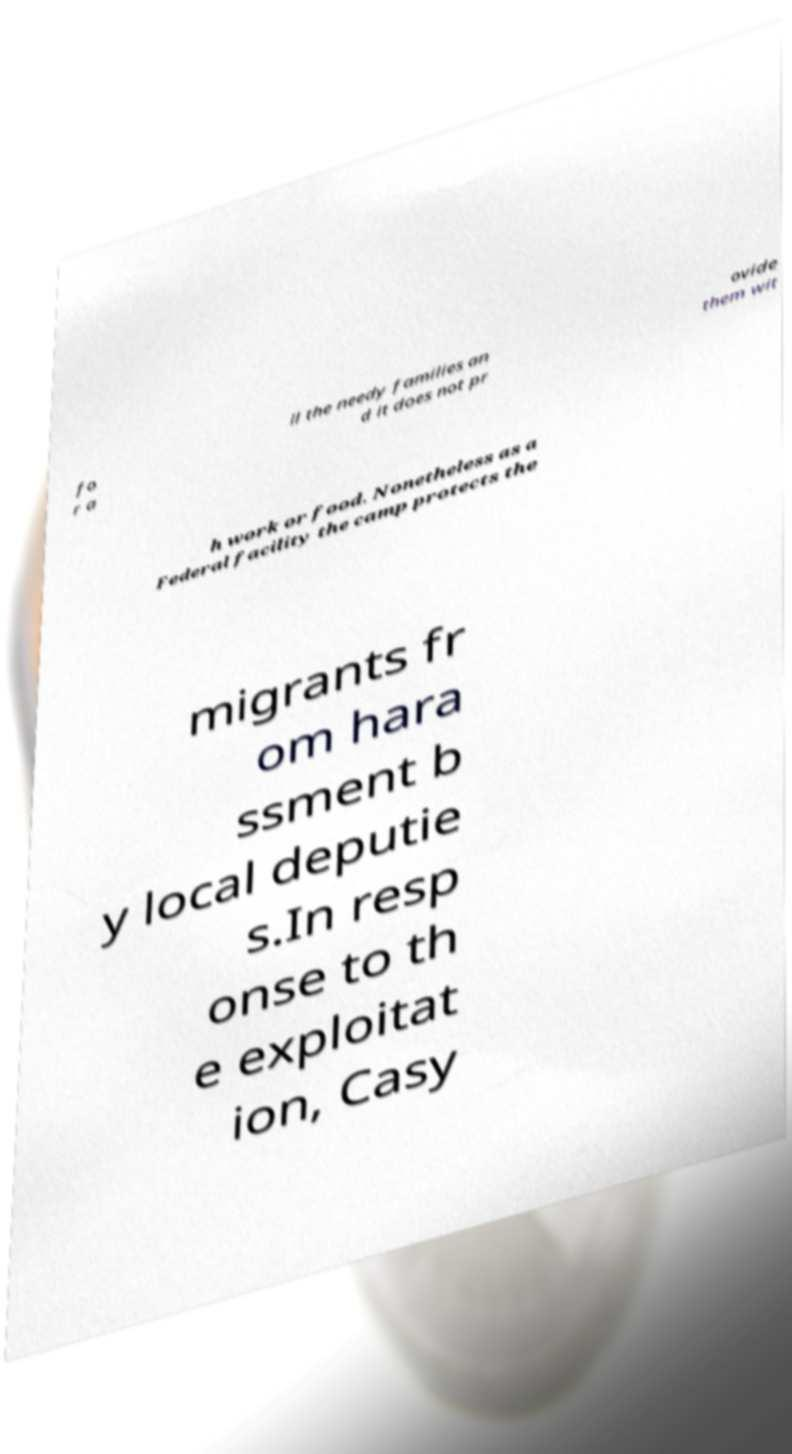I need the written content from this picture converted into text. Can you do that? fo r a ll the needy families an d it does not pr ovide them wit h work or food. Nonetheless as a Federal facility the camp protects the migrants fr om hara ssment b y local deputie s.In resp onse to th e exploitat ion, Casy 